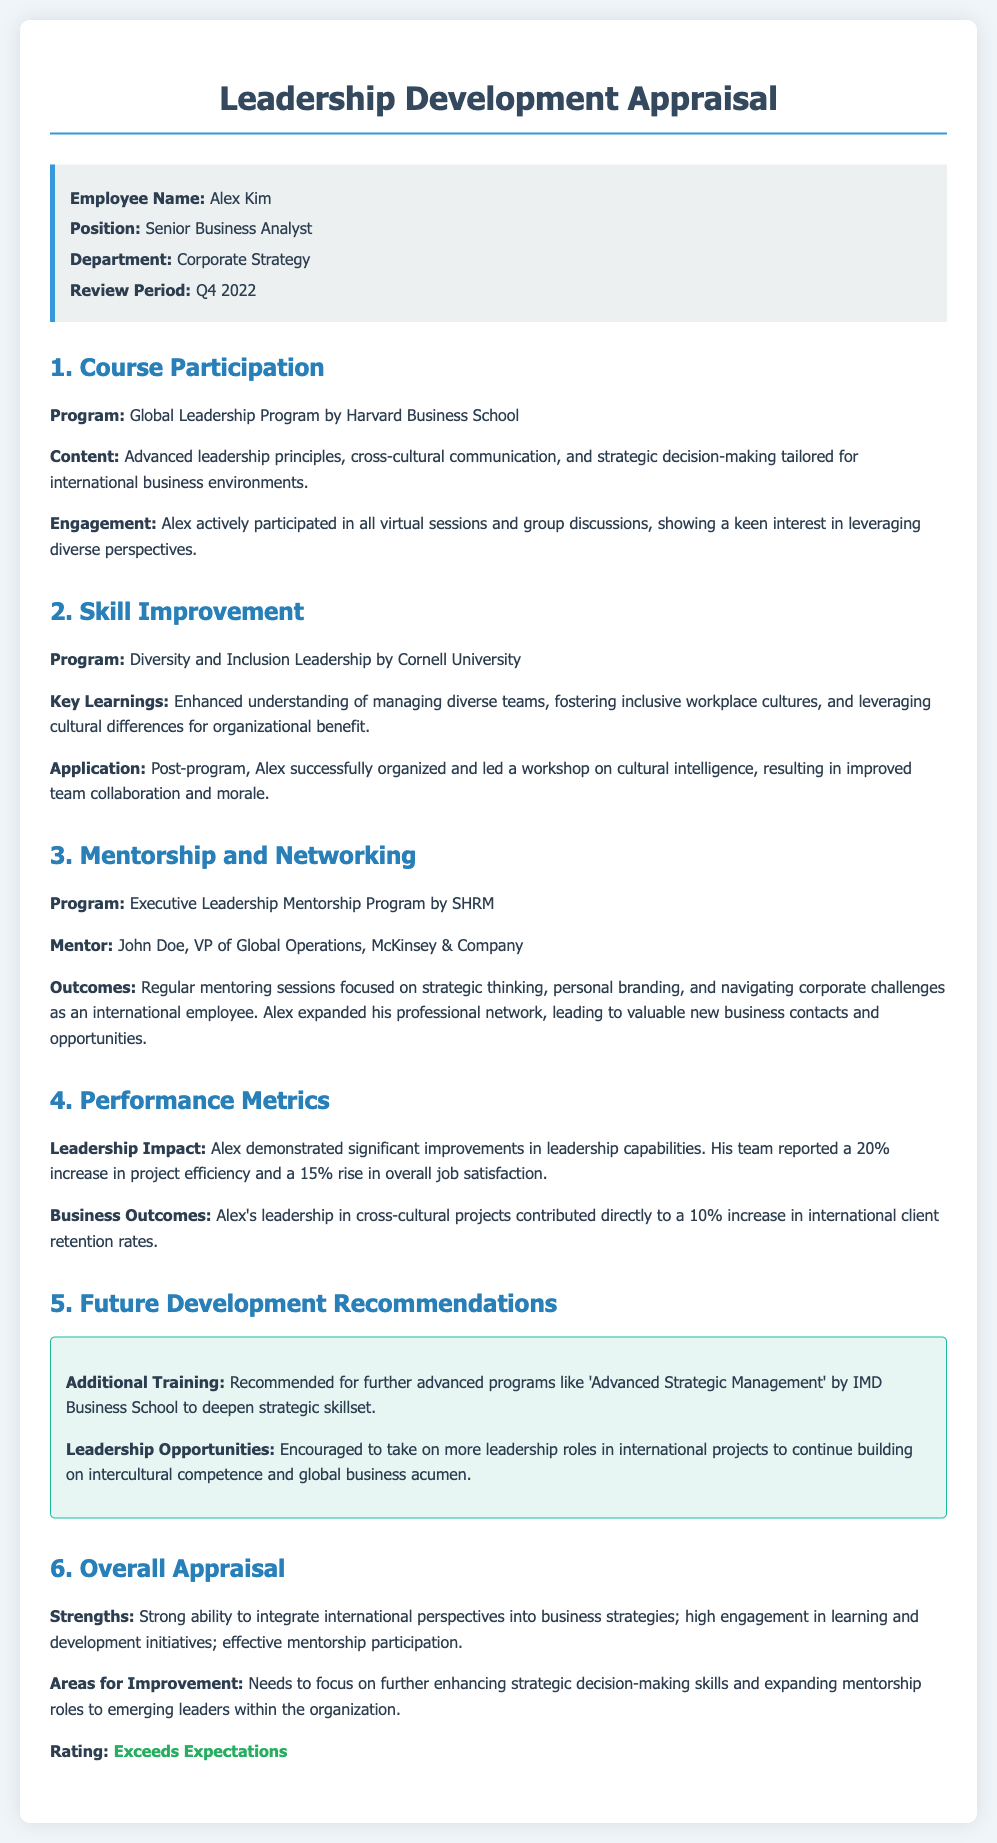What is the employee's name? The employee's name is mentioned in the info box at the beginning of the document.
Answer: Alex Kim What is the position of Alex Kim? The position of Alex Kim is stated in the info box, specifying his role within the organization.
Answer: Senior Business Analyst Which program did Alex participate in for advanced leadership? This information is provided in the course participation section of the document.
Answer: Global Leadership Program by Harvard Business School What percentage increase did Alex's team report in project efficiency? The performance metrics section indicates this specific improvement within team dynamics.
Answer: 20% Who was Alex's mentor in the Executive Leadership Mentorship Program? The mentor's name is highlighted in the mentorship and networking section, showing his guidance for Alex.
Answer: John Doe What was one of the key learnings from the Diversity and Inclusion Leadership program? The document lists important insights gained from that program, focusing on team management.
Answer: Managing diverse teams What is recommended for Alex's future development? The future development recommendations section outlines specific areas for further improvement and training.
Answer: Additional Training What is Alex's overall appraisal rating? The overall appraisal section gives a summary of performance, including a specific rating.
Answer: Exceeds Expectations According to the document, what are Alex's strengths? The strengths are mentioned explicitly in the overall appraisal section, summarizing his competencies.
Answer: Strong ability to integrate international perspectives into business strategies 